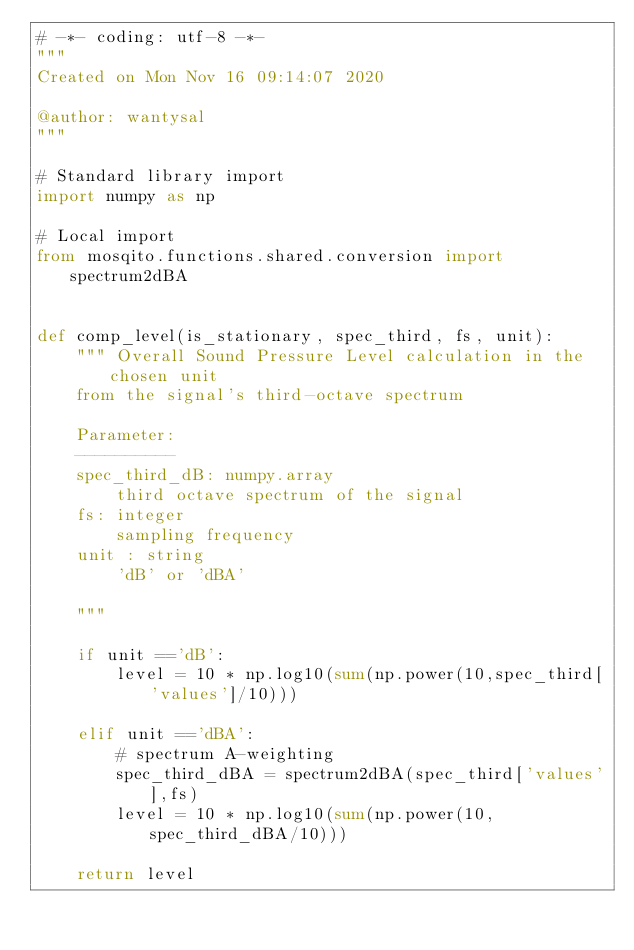Convert code to text. <code><loc_0><loc_0><loc_500><loc_500><_Python_># -*- coding: utf-8 -*-
"""
Created on Mon Nov 16 09:14:07 2020

@author: wantysal
"""

# Standard library import
import numpy as np

# Local import
from mosqito.functions.shared.conversion import spectrum2dBA


def comp_level(is_stationary, spec_third, fs, unit):
    """ Overall Sound Pressure Level calculation in the chosen unit 
    from the signal's third-octave spectrum
        
    Parameter:
    ----------
    spec_third_dB: numpy.array
        third octave spectrum of the signal 
    fs: integer
        sampling frequency
    unit : string
        'dB' or 'dBA'
            
    """        

    if unit =='dB':
        level = 10 * np.log10(sum(np.power(10,spec_third['values']/10)))       
        
    elif unit =='dBA':
        # spectrum A-weighting
        spec_third_dBA = spectrum2dBA(spec_third['values'],fs)
        level = 10 * np.log10(sum(np.power(10,spec_third_dBA/10)))

    return level</code> 